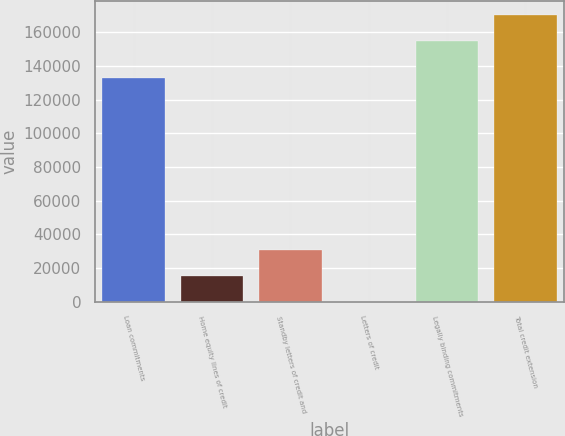<chart> <loc_0><loc_0><loc_500><loc_500><bar_chart><fcel>Loan commitments<fcel>Home equity lines of credit<fcel>Standby letters of credit and<fcel>Letters of credit<fcel>Legally binding commitments<fcel>Total credit extension<nl><fcel>133063<fcel>15554.8<fcel>31006.6<fcel>103<fcel>154621<fcel>170073<nl></chart> 